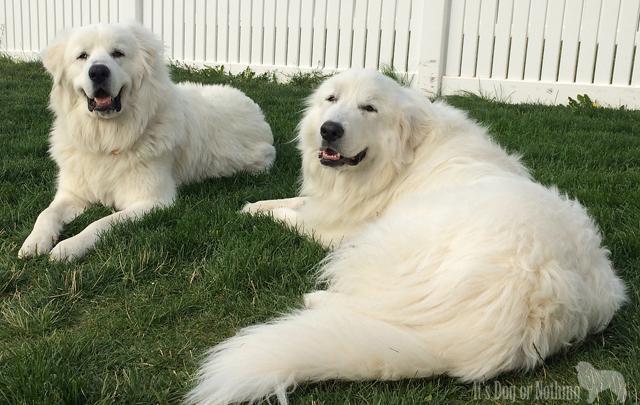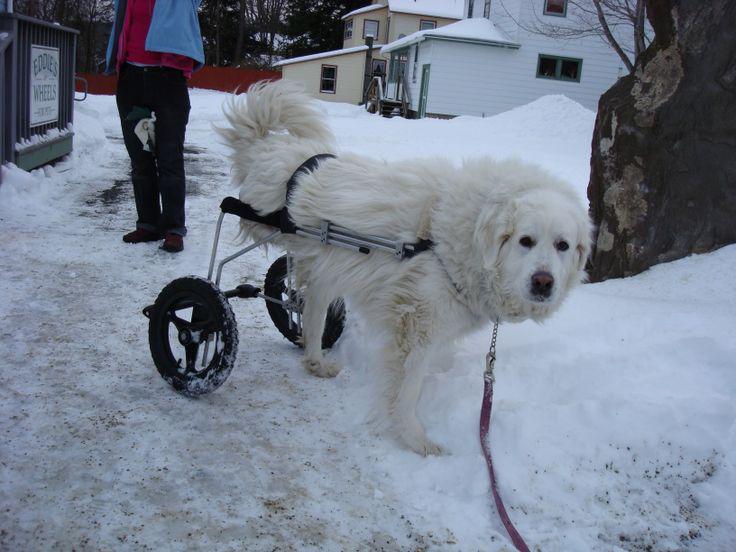The first image is the image on the left, the second image is the image on the right. Examine the images to the left and right. Is the description "An animal in the image on the left has wheels." accurate? Answer yes or no. No. 